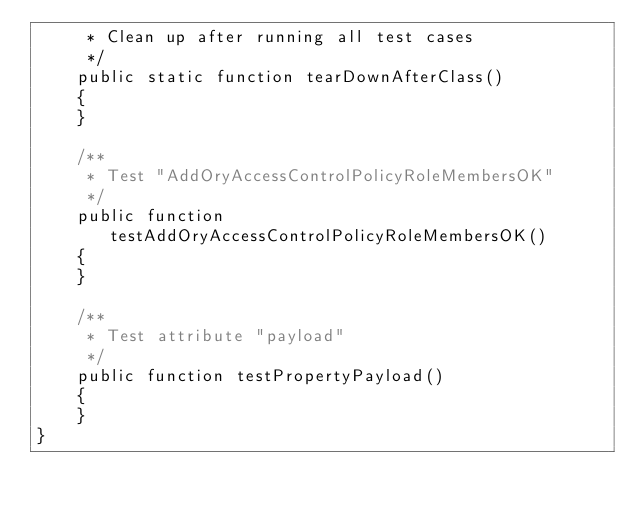<code> <loc_0><loc_0><loc_500><loc_500><_PHP_>     * Clean up after running all test cases
     */
    public static function tearDownAfterClass()
    {
    }

    /**
     * Test "AddOryAccessControlPolicyRoleMembersOK"
     */
    public function testAddOryAccessControlPolicyRoleMembersOK()
    {
    }

    /**
     * Test attribute "payload"
     */
    public function testPropertyPayload()
    {
    }
}
</code> 